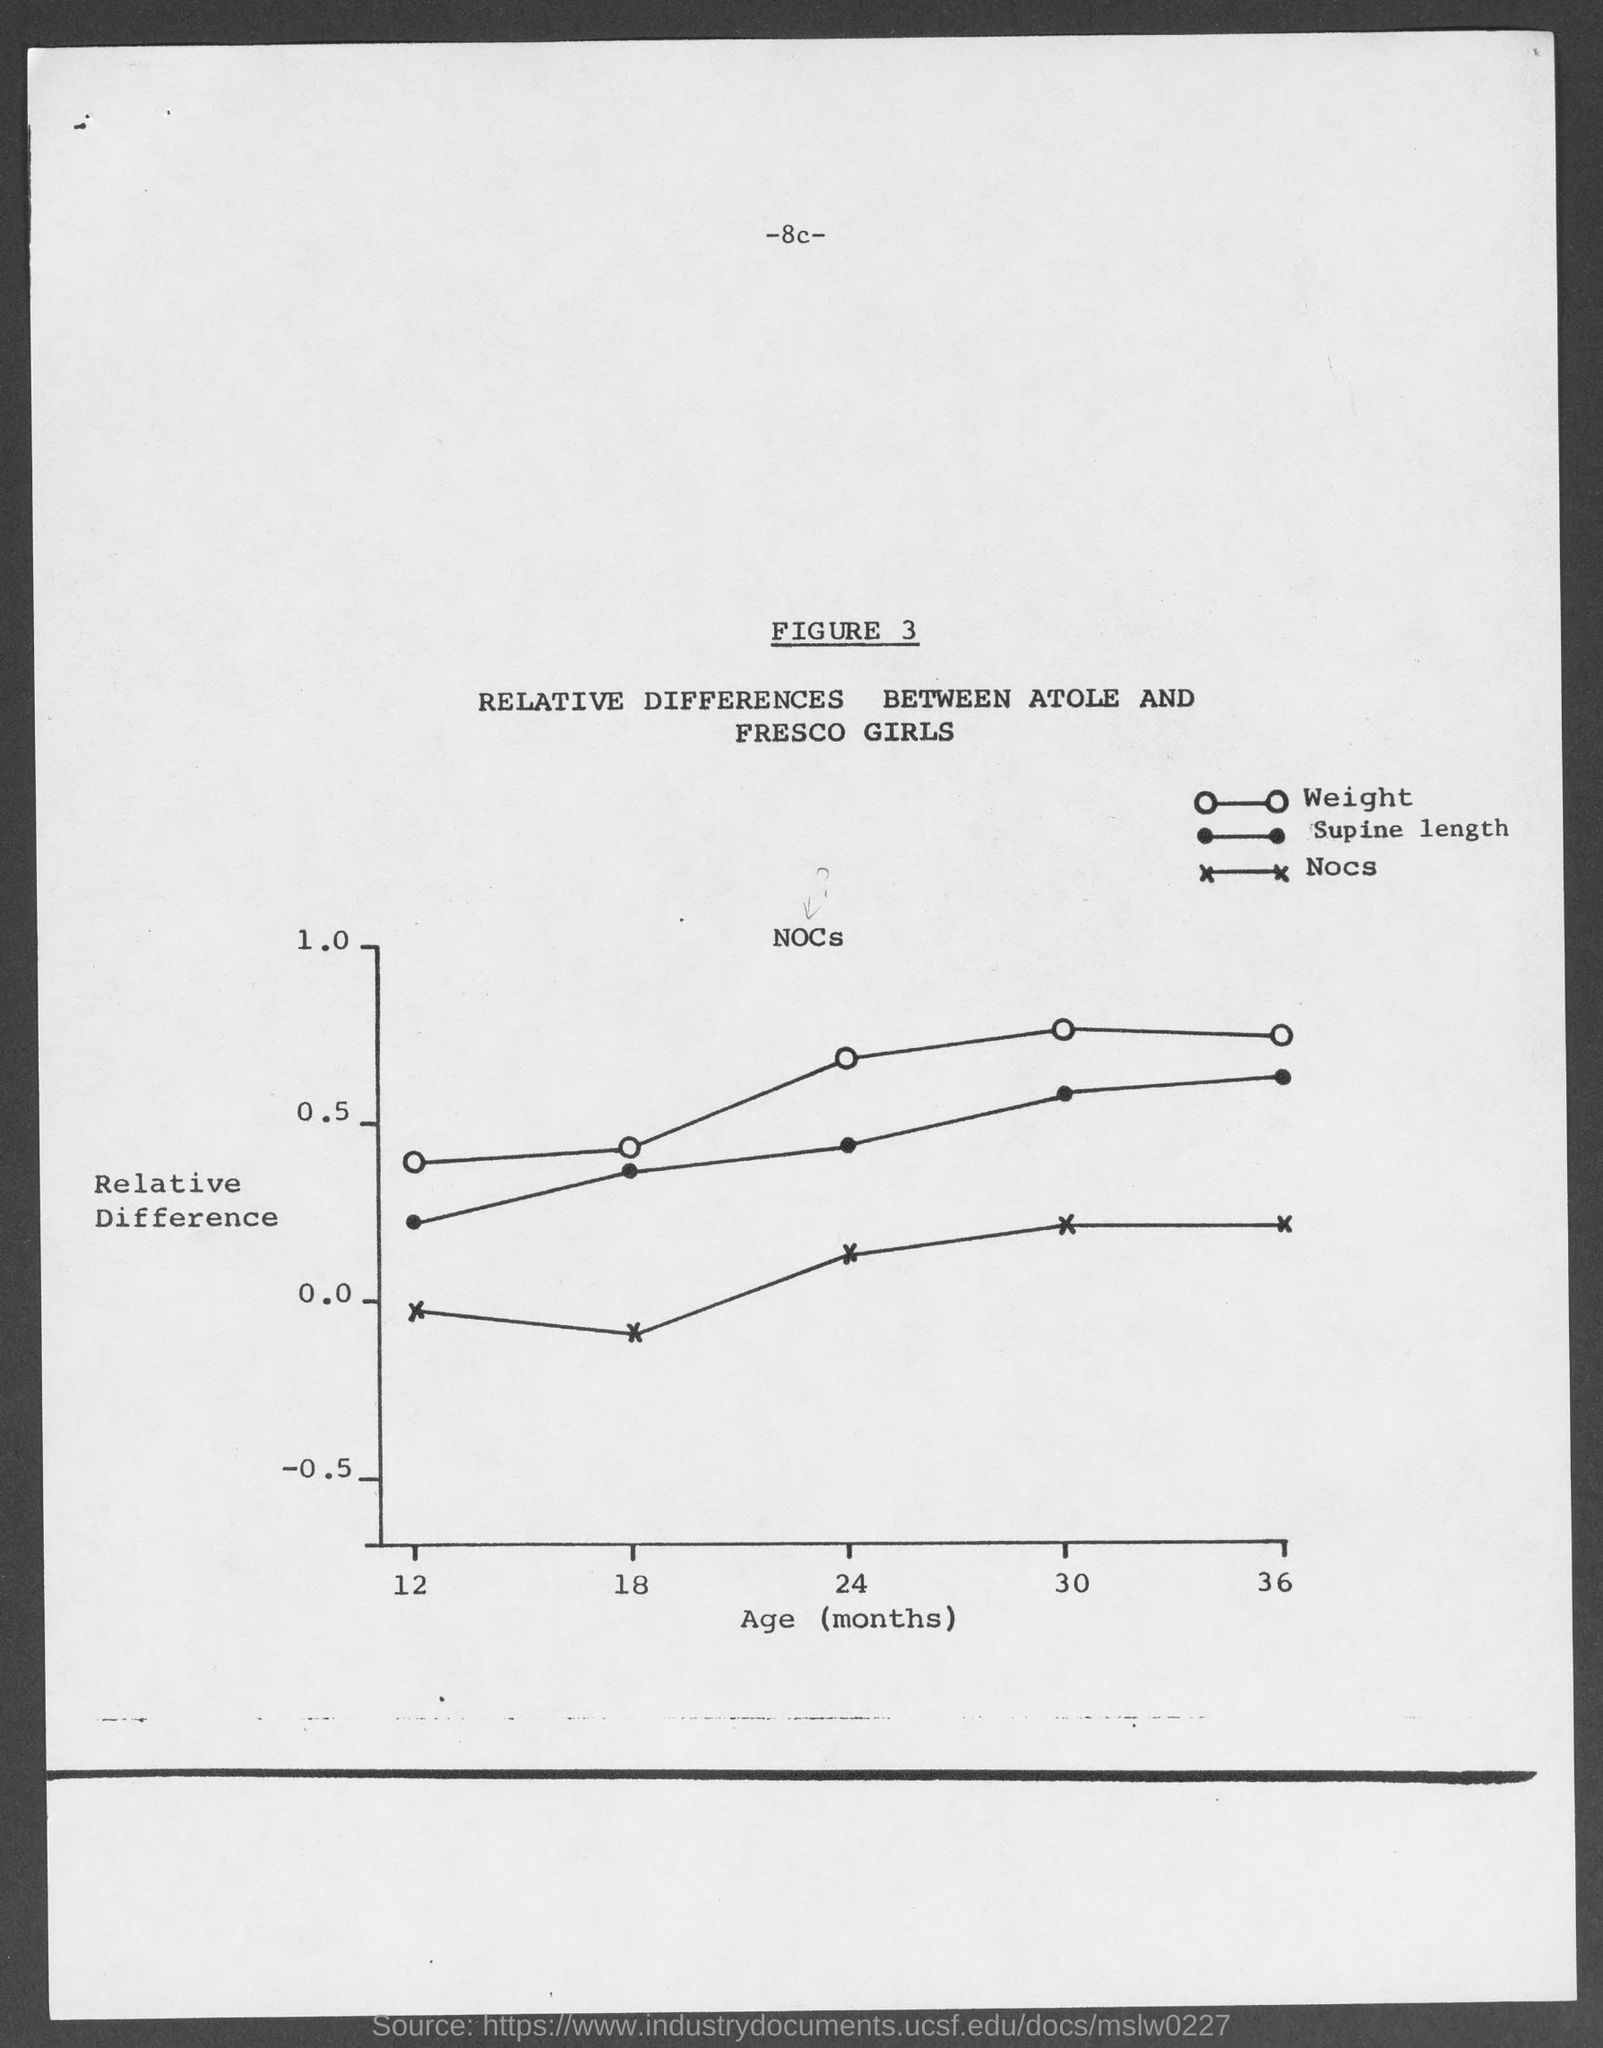Point out several critical features in this image. The figure number is 3. 